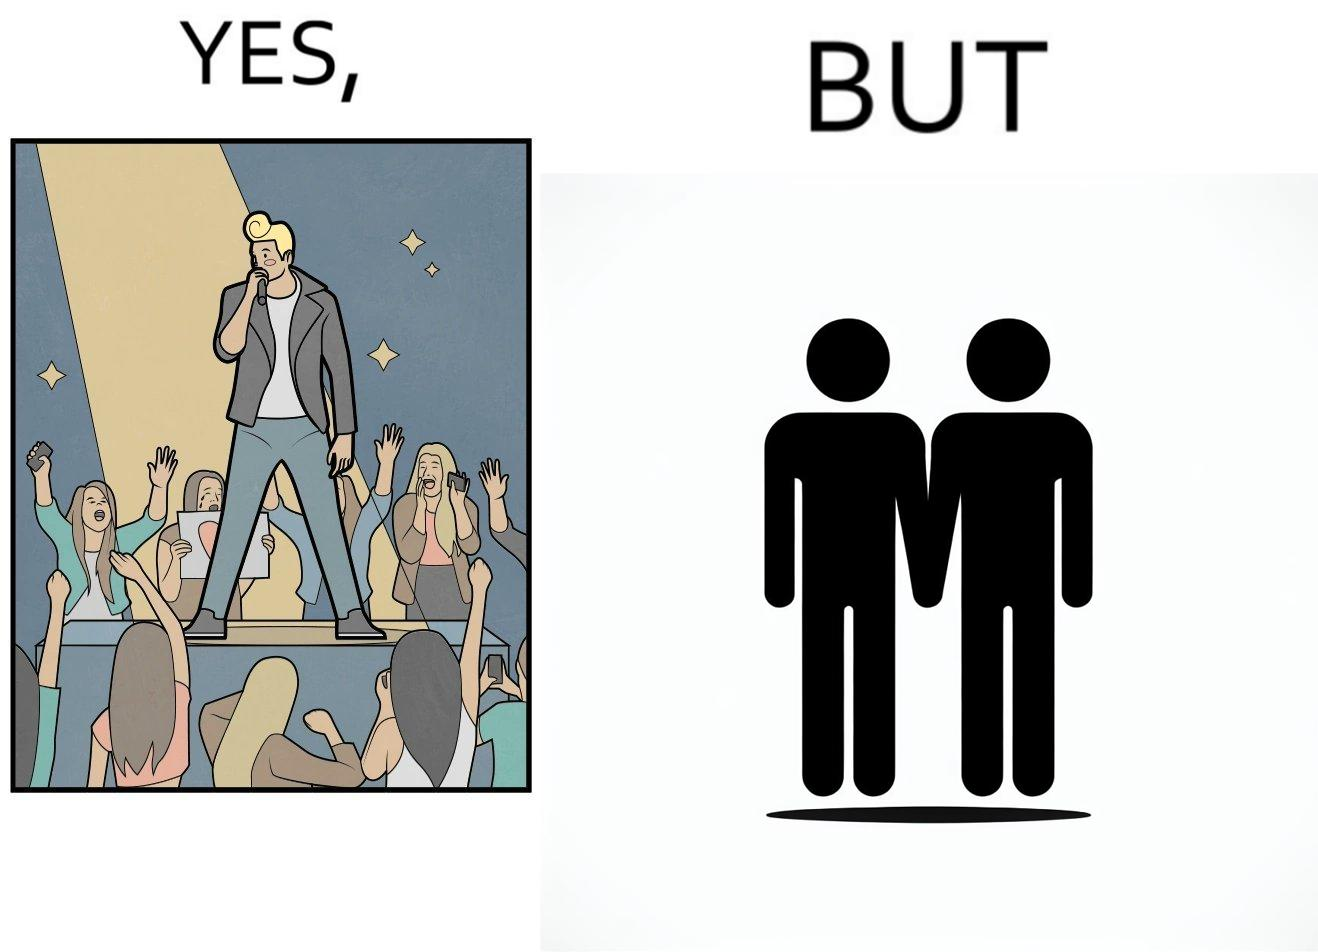What is shown in the left half versus the right half of this image? In the left part of the image: The person shows a man singing on a platform under a spotlight. There are several girls around the platform enjoying his singing and cheering for him. A few girls are taking his photos using their phone and a few also have a poster with heart drawn on it. In the right part of the image: The image shows two men holding hands. 